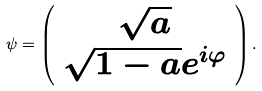Convert formula to latex. <formula><loc_0><loc_0><loc_500><loc_500>\psi = \left ( \begin{array} { c } \sqrt { a } \\ \sqrt { 1 - a } e ^ { i \varphi } \\ \end{array} \right ) .</formula> 